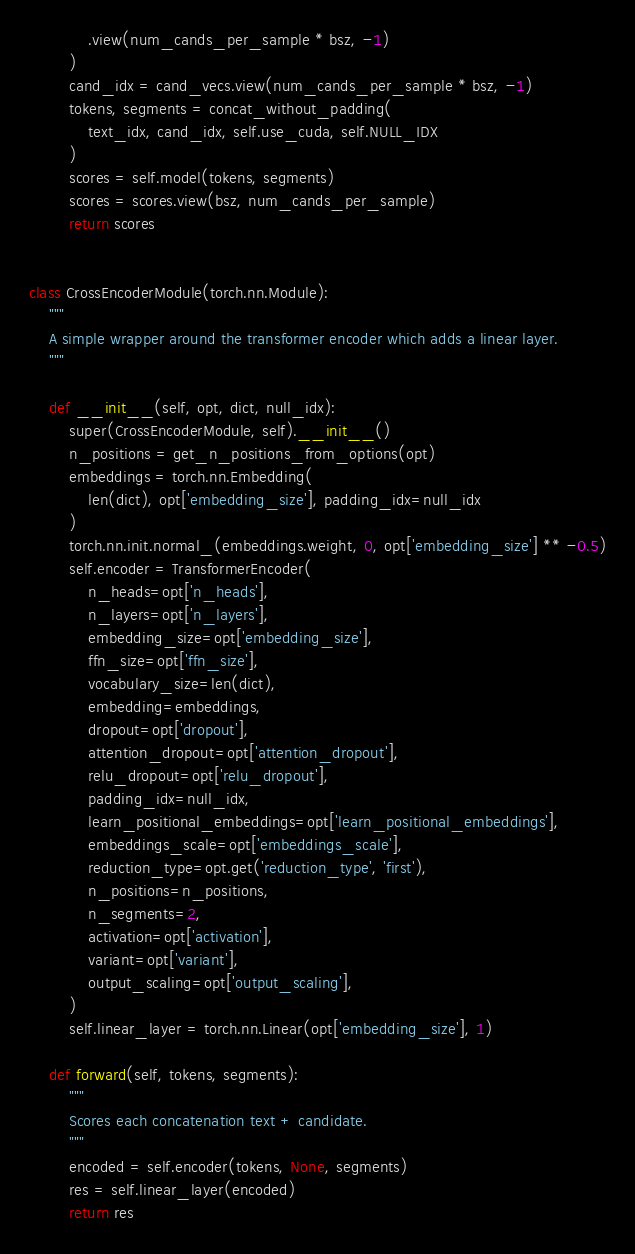Convert code to text. <code><loc_0><loc_0><loc_500><loc_500><_Python_>            .view(num_cands_per_sample * bsz, -1)
        )
        cand_idx = cand_vecs.view(num_cands_per_sample * bsz, -1)
        tokens, segments = concat_without_padding(
            text_idx, cand_idx, self.use_cuda, self.NULL_IDX
        )
        scores = self.model(tokens, segments)
        scores = scores.view(bsz, num_cands_per_sample)
        return scores


class CrossEncoderModule(torch.nn.Module):
    """
    A simple wrapper around the transformer encoder which adds a linear layer.
    """

    def __init__(self, opt, dict, null_idx):
        super(CrossEncoderModule, self).__init__()
        n_positions = get_n_positions_from_options(opt)
        embeddings = torch.nn.Embedding(
            len(dict), opt['embedding_size'], padding_idx=null_idx
        )
        torch.nn.init.normal_(embeddings.weight, 0, opt['embedding_size'] ** -0.5)
        self.encoder = TransformerEncoder(
            n_heads=opt['n_heads'],
            n_layers=opt['n_layers'],
            embedding_size=opt['embedding_size'],
            ffn_size=opt['ffn_size'],
            vocabulary_size=len(dict),
            embedding=embeddings,
            dropout=opt['dropout'],
            attention_dropout=opt['attention_dropout'],
            relu_dropout=opt['relu_dropout'],
            padding_idx=null_idx,
            learn_positional_embeddings=opt['learn_positional_embeddings'],
            embeddings_scale=opt['embeddings_scale'],
            reduction_type=opt.get('reduction_type', 'first'),
            n_positions=n_positions,
            n_segments=2,
            activation=opt['activation'],
            variant=opt['variant'],
            output_scaling=opt['output_scaling'],
        )
        self.linear_layer = torch.nn.Linear(opt['embedding_size'], 1)

    def forward(self, tokens, segments):
        """
        Scores each concatenation text + candidate.
        """
        encoded = self.encoder(tokens, None, segments)
        res = self.linear_layer(encoded)
        return res
</code> 